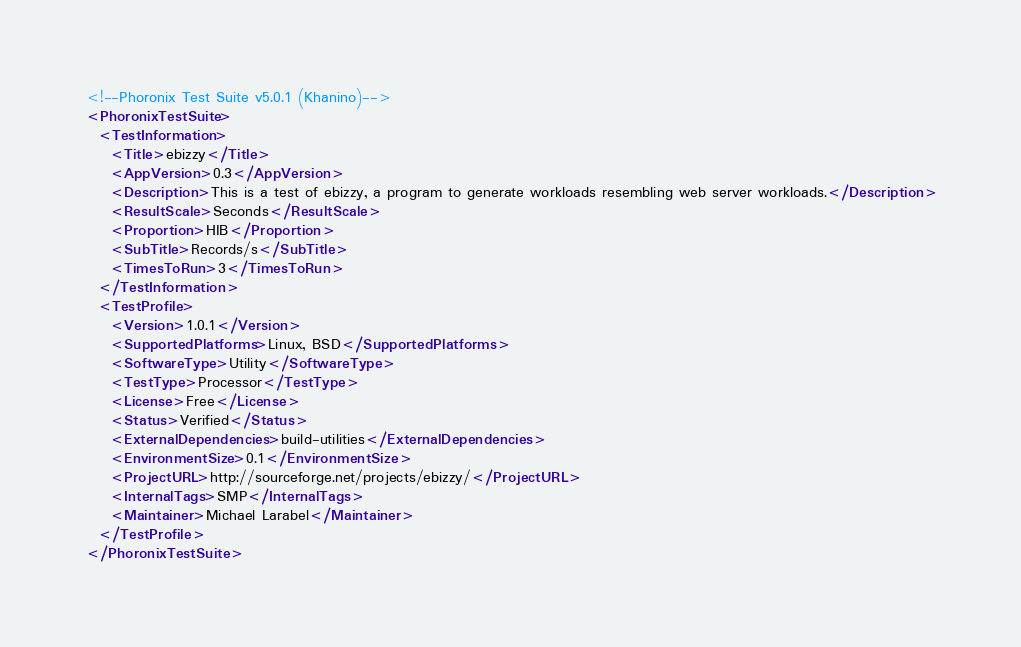<code> <loc_0><loc_0><loc_500><loc_500><_XML_><!--Phoronix Test Suite v5.0.1 (Khanino)-->
<PhoronixTestSuite>
  <TestInformation>
    <Title>ebizzy</Title>
    <AppVersion>0.3</AppVersion>
    <Description>This is a test of ebizzy, a program to generate workloads resembling web server workloads.</Description>
    <ResultScale>Seconds</ResultScale>
    <Proportion>HIB</Proportion>
    <SubTitle>Records/s</SubTitle>
    <TimesToRun>3</TimesToRun>
  </TestInformation>
  <TestProfile>
    <Version>1.0.1</Version>
    <SupportedPlatforms>Linux, BSD</SupportedPlatforms>
    <SoftwareType>Utility</SoftwareType>
    <TestType>Processor</TestType>
    <License>Free</License>
    <Status>Verified</Status>
    <ExternalDependencies>build-utilities</ExternalDependencies>
    <EnvironmentSize>0.1</EnvironmentSize>
    <ProjectURL>http://sourceforge.net/projects/ebizzy/</ProjectURL>
    <InternalTags>SMP</InternalTags>
    <Maintainer>Michael Larabel</Maintainer>
  </TestProfile>
</PhoronixTestSuite>
</code> 